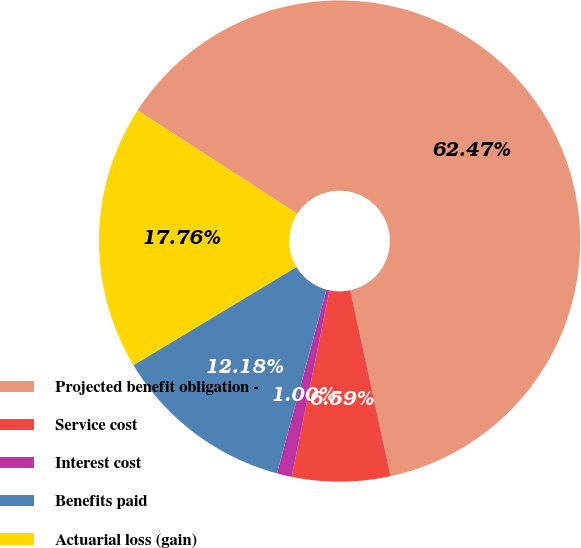Convert chart. <chart><loc_0><loc_0><loc_500><loc_500><pie_chart><fcel>Projected benefit obligation -<fcel>Service cost<fcel>Interest cost<fcel>Benefits paid<fcel>Actuarial loss (gain)<nl><fcel>62.47%<fcel>6.59%<fcel>1.0%<fcel>12.18%<fcel>17.76%<nl></chart> 